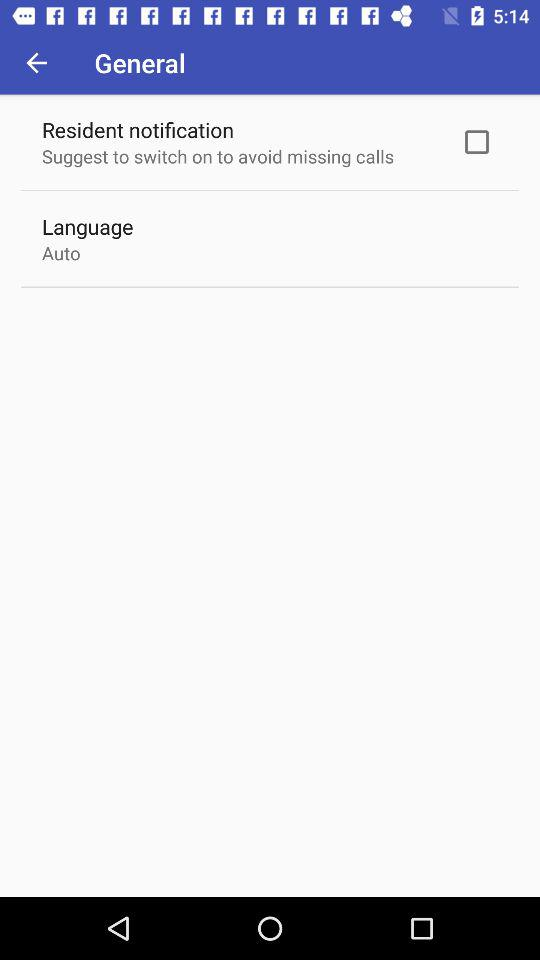How many more options are there for the Resident notification than the Language setting?
Answer the question using a single word or phrase. 1 